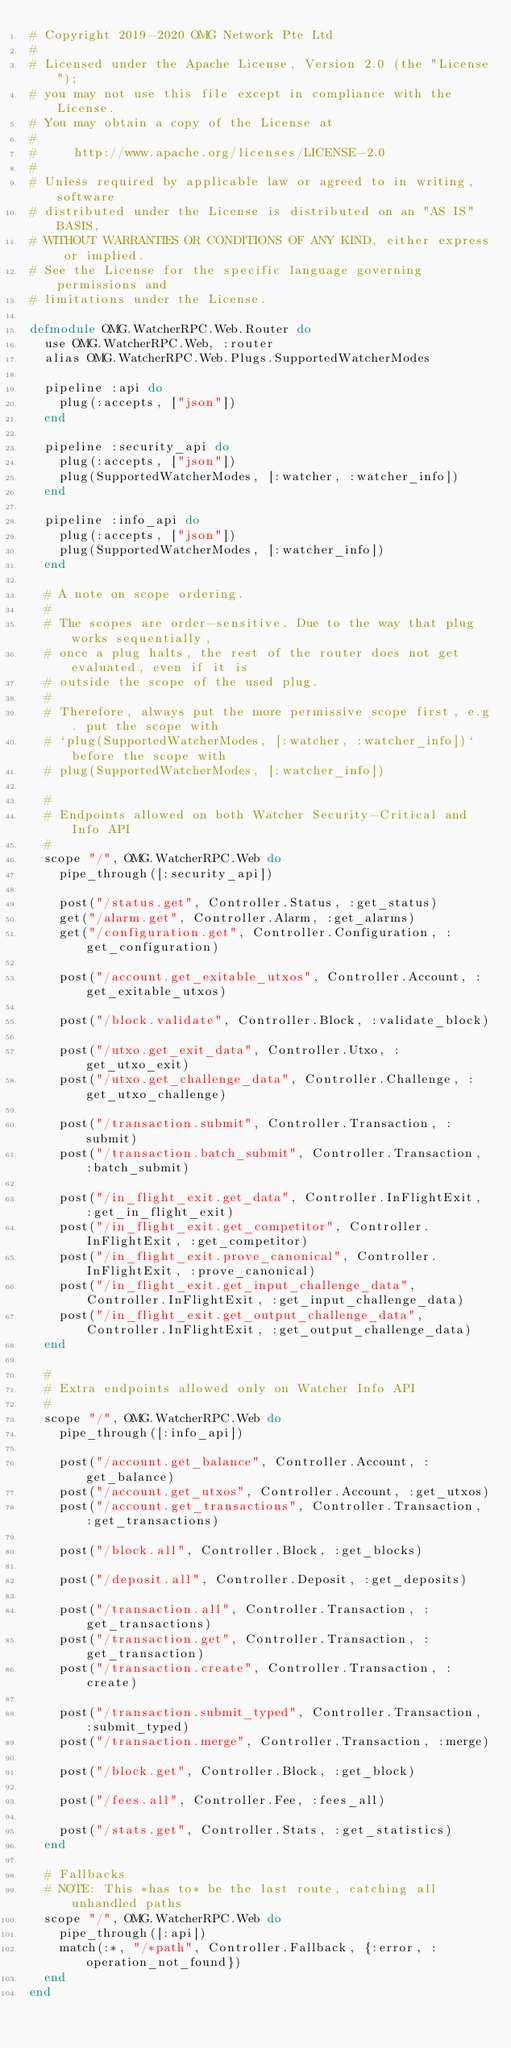<code> <loc_0><loc_0><loc_500><loc_500><_Elixir_># Copyright 2019-2020 OMG Network Pte Ltd
#
# Licensed under the Apache License, Version 2.0 (the "License");
# you may not use this file except in compliance with the License.
# You may obtain a copy of the License at
#
#     http://www.apache.org/licenses/LICENSE-2.0
#
# Unless required by applicable law or agreed to in writing, software
# distributed under the License is distributed on an "AS IS" BASIS,
# WITHOUT WARRANTIES OR CONDITIONS OF ANY KIND, either express or implied.
# See the License for the specific language governing permissions and
# limitations under the License.

defmodule OMG.WatcherRPC.Web.Router do
  use OMG.WatcherRPC.Web, :router
  alias OMG.WatcherRPC.Web.Plugs.SupportedWatcherModes

  pipeline :api do
    plug(:accepts, ["json"])
  end

  pipeline :security_api do
    plug(:accepts, ["json"])
    plug(SupportedWatcherModes, [:watcher, :watcher_info])
  end

  pipeline :info_api do
    plug(:accepts, ["json"])
    plug(SupportedWatcherModes, [:watcher_info])
  end

  # A note on scope ordering.
  #
  # The scopes are order-sensitive. Due to the way that plug works sequentially,
  # once a plug halts, the rest of the router does not get evaluated, even if it is
  # outside the scope of the used plug.
  #
  # Therefore, always put the more permissive scope first, e.g. put the scope with
  # `plug(SupportedWatcherModes, [:watcher, :watcher_info])` before the scope with
  # plug(SupportedWatcherModes, [:watcher_info])

  #
  # Endpoints allowed on both Watcher Security-Critical and Info API
  #
  scope "/", OMG.WatcherRPC.Web do
    pipe_through([:security_api])

    post("/status.get", Controller.Status, :get_status)
    get("/alarm.get", Controller.Alarm, :get_alarms)
    get("/configuration.get", Controller.Configuration, :get_configuration)

    post("/account.get_exitable_utxos", Controller.Account, :get_exitable_utxos)

    post("/block.validate", Controller.Block, :validate_block)

    post("/utxo.get_exit_data", Controller.Utxo, :get_utxo_exit)
    post("/utxo.get_challenge_data", Controller.Challenge, :get_utxo_challenge)

    post("/transaction.submit", Controller.Transaction, :submit)
    post("/transaction.batch_submit", Controller.Transaction, :batch_submit)

    post("/in_flight_exit.get_data", Controller.InFlightExit, :get_in_flight_exit)
    post("/in_flight_exit.get_competitor", Controller.InFlightExit, :get_competitor)
    post("/in_flight_exit.prove_canonical", Controller.InFlightExit, :prove_canonical)
    post("/in_flight_exit.get_input_challenge_data", Controller.InFlightExit, :get_input_challenge_data)
    post("/in_flight_exit.get_output_challenge_data", Controller.InFlightExit, :get_output_challenge_data)
  end

  #
  # Extra endpoints allowed only on Watcher Info API
  #
  scope "/", OMG.WatcherRPC.Web do
    pipe_through([:info_api])

    post("/account.get_balance", Controller.Account, :get_balance)
    post("/account.get_utxos", Controller.Account, :get_utxos)
    post("/account.get_transactions", Controller.Transaction, :get_transactions)

    post("/block.all", Controller.Block, :get_blocks)

    post("/deposit.all", Controller.Deposit, :get_deposits)

    post("/transaction.all", Controller.Transaction, :get_transactions)
    post("/transaction.get", Controller.Transaction, :get_transaction)
    post("/transaction.create", Controller.Transaction, :create)

    post("/transaction.submit_typed", Controller.Transaction, :submit_typed)
    post("/transaction.merge", Controller.Transaction, :merge)

    post("/block.get", Controller.Block, :get_block)

    post("/fees.all", Controller.Fee, :fees_all)

    post("/stats.get", Controller.Stats, :get_statistics)
  end

  # Fallbacks
  # NOTE: This *has to* be the last route, catching all unhandled paths
  scope "/", OMG.WatcherRPC.Web do
    pipe_through([:api])
    match(:*, "/*path", Controller.Fallback, {:error, :operation_not_found})
  end
end
</code> 